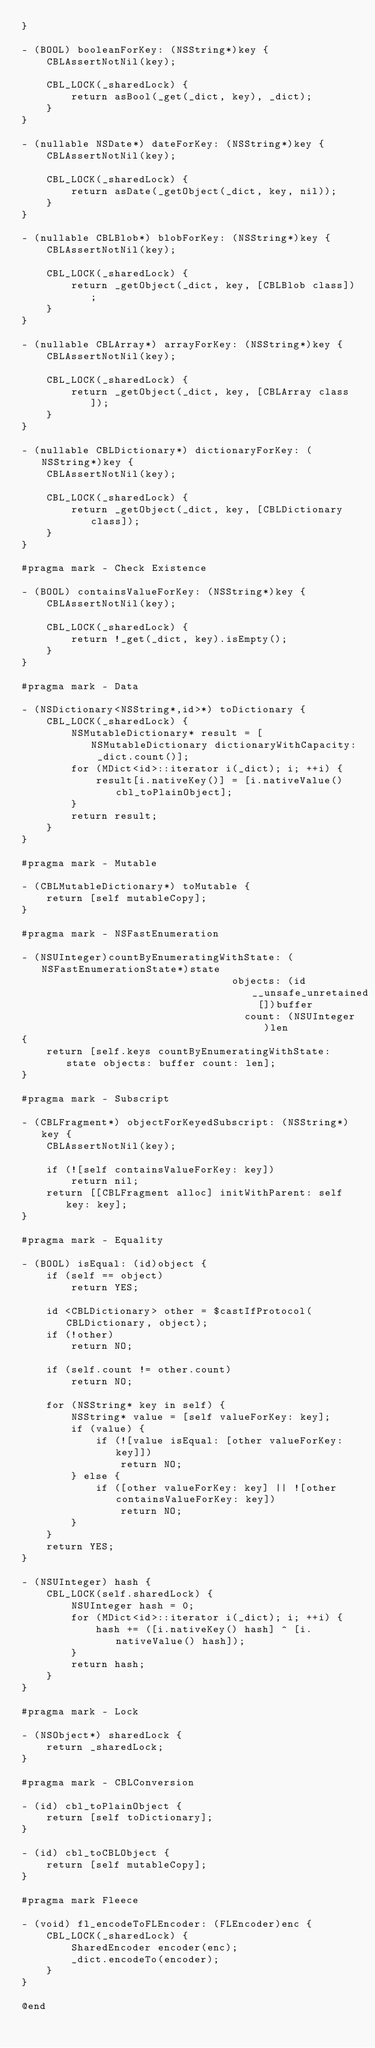Convert code to text. <code><loc_0><loc_0><loc_500><loc_500><_ObjectiveC_>}

- (BOOL) booleanForKey: (NSString*)key {
    CBLAssertNotNil(key);
    
    CBL_LOCK(_sharedLock) {
        return asBool(_get(_dict, key), _dict);
    }
}

- (nullable NSDate*) dateForKey: (NSString*)key {
    CBLAssertNotNil(key);
    
    CBL_LOCK(_sharedLock) {
        return asDate(_getObject(_dict, key, nil));
    }
}

- (nullable CBLBlob*) blobForKey: (NSString*)key {
    CBLAssertNotNil(key);
    
    CBL_LOCK(_sharedLock) {
        return _getObject(_dict, key, [CBLBlob class]);
    }
}

- (nullable CBLArray*) arrayForKey: (NSString*)key {
    CBLAssertNotNil(key);
    
    CBL_LOCK(_sharedLock) {
        return _getObject(_dict, key, [CBLArray class]);
    }
}

- (nullable CBLDictionary*) dictionaryForKey: (NSString*)key {
    CBLAssertNotNil(key);
    
    CBL_LOCK(_sharedLock) {
        return _getObject(_dict, key, [CBLDictionary class]);
    }
}

#pragma mark - Check Existence

- (BOOL) containsValueForKey: (NSString*)key {
    CBLAssertNotNil(key);
    
    CBL_LOCK(_sharedLock) {
        return !_get(_dict, key).isEmpty();
    }
}

#pragma mark - Data

- (NSDictionary<NSString*,id>*) toDictionary {
    CBL_LOCK(_sharedLock) {
        NSMutableDictionary* result = [NSMutableDictionary dictionaryWithCapacity: _dict.count()];
        for (MDict<id>::iterator i(_dict); i; ++i) {
            result[i.nativeKey()] = [i.nativeValue() cbl_toPlainObject];
        }
        return result;
    }
}

#pragma mark - Mutable

- (CBLMutableDictionary*) toMutable {
    return [self mutableCopy];
}

#pragma mark - NSFastEnumeration

- (NSUInteger)countByEnumeratingWithState: (NSFastEnumerationState*)state
                                  objects: (id __unsafe_unretained [])buffer
                                    count: (NSUInteger)len
{
    return [self.keys countByEnumeratingWithState: state objects: buffer count: len];
}

#pragma mark - Subscript

- (CBLFragment*) objectForKeyedSubscript: (NSString*)key {
    CBLAssertNotNil(key);
    
    if (![self containsValueForKey: key])
        return nil;
    return [[CBLFragment alloc] initWithParent: self key: key];
}

#pragma mark - Equality

- (BOOL) isEqual: (id)object {
    if (self == object)
        return YES;
    
    id <CBLDictionary> other = $castIfProtocol(CBLDictionary, object);
    if (!other)
        return NO;
    
    if (self.count != other.count)
        return NO;
    
    for (NSString* key in self) {
        NSString* value = [self valueForKey: key];
        if (value) {
            if (![value isEqual: [other valueForKey: key]])
                return NO;
        } else {
            if ([other valueForKey: key] || ![other containsValueForKey: key])
                return NO;
        }
    }
    return YES;
}

- (NSUInteger) hash {
    CBL_LOCK(self.sharedLock) {
        NSUInteger hash = 0;
        for (MDict<id>::iterator i(_dict); i; ++i) {
            hash += ([i.nativeKey() hash] ^ [i.nativeValue() hash]);
        }
        return hash;
    }
}

#pragma mark - Lock

- (NSObject*) sharedLock {
    return _sharedLock;
}

#pragma mark - CBLConversion

- (id) cbl_toPlainObject {
    return [self toDictionary];
}

- (id) cbl_toCBLObject {
    return [self mutableCopy];
}

#pragma mark Fleece

- (void) fl_encodeToFLEncoder: (FLEncoder)enc {
    CBL_LOCK(_sharedLock) {
        SharedEncoder encoder(enc);
        _dict.encodeTo(encoder);
    }
}

@end
</code> 